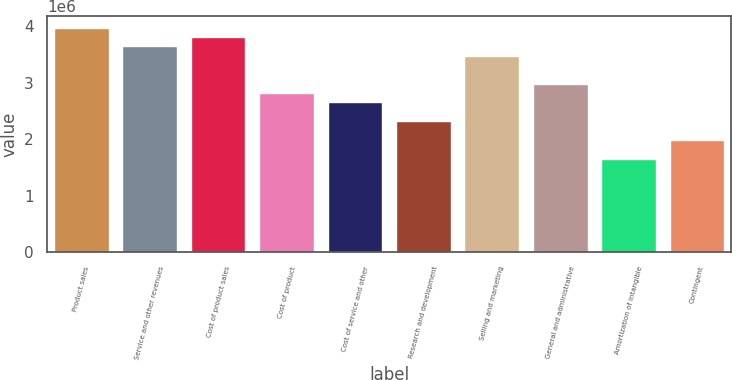Convert chart to OTSL. <chart><loc_0><loc_0><loc_500><loc_500><bar_chart><fcel>Product sales<fcel>Service and other revenues<fcel>Cost of product sales<fcel>Cost of product<fcel>Cost of service and other<fcel>Research and development<fcel>Selling and marketing<fcel>General and administrative<fcel>Amortization of intangible<fcel>Contingent<nl><fcel>3.97855e+06<fcel>3.647e+06<fcel>3.81277e+06<fcel>2.81814e+06<fcel>2.65236e+06<fcel>2.32082e+06<fcel>3.48123e+06<fcel>2.98391e+06<fcel>1.65773e+06<fcel>1.98927e+06<nl></chart> 